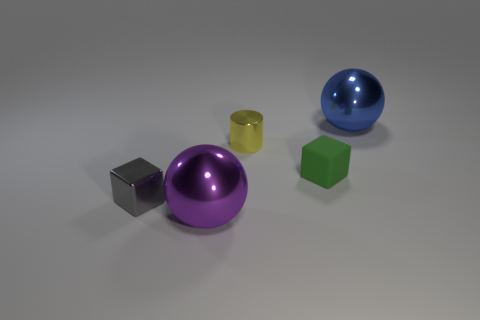What is the size of the gray cube that is made of the same material as the blue thing?
Your response must be concise. Small. There is a big shiny object behind the rubber object; how many metallic spheres are in front of it?
Your answer should be compact. 1. Are the sphere in front of the small green rubber cube and the yellow cylinder made of the same material?
Your answer should be compact. Yes. Is there any other thing that is made of the same material as the tiny gray thing?
Offer a terse response. Yes. What is the size of the metallic object that is on the left side of the shiny ball that is to the left of the blue metal thing?
Keep it short and to the point. Small. There is a sphere that is in front of the big metallic ball behind the small thing that is to the left of the tiny cylinder; how big is it?
Ensure brevity in your answer.  Large. Do the big metal thing that is behind the small yellow object and the tiny object that is on the right side of the tiny shiny cylinder have the same shape?
Make the answer very short. No. What number of other things are there of the same color as the tiny metal cylinder?
Make the answer very short. 0. There is a object that is left of the purple metal object; does it have the same size as the big purple shiny object?
Make the answer very short. No. Is the small block in front of the tiny green rubber cube made of the same material as the cube on the right side of the tiny gray metallic object?
Make the answer very short. No. 